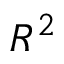Convert formula to latex. <formula><loc_0><loc_0><loc_500><loc_500>R ^ { 2 }</formula> 